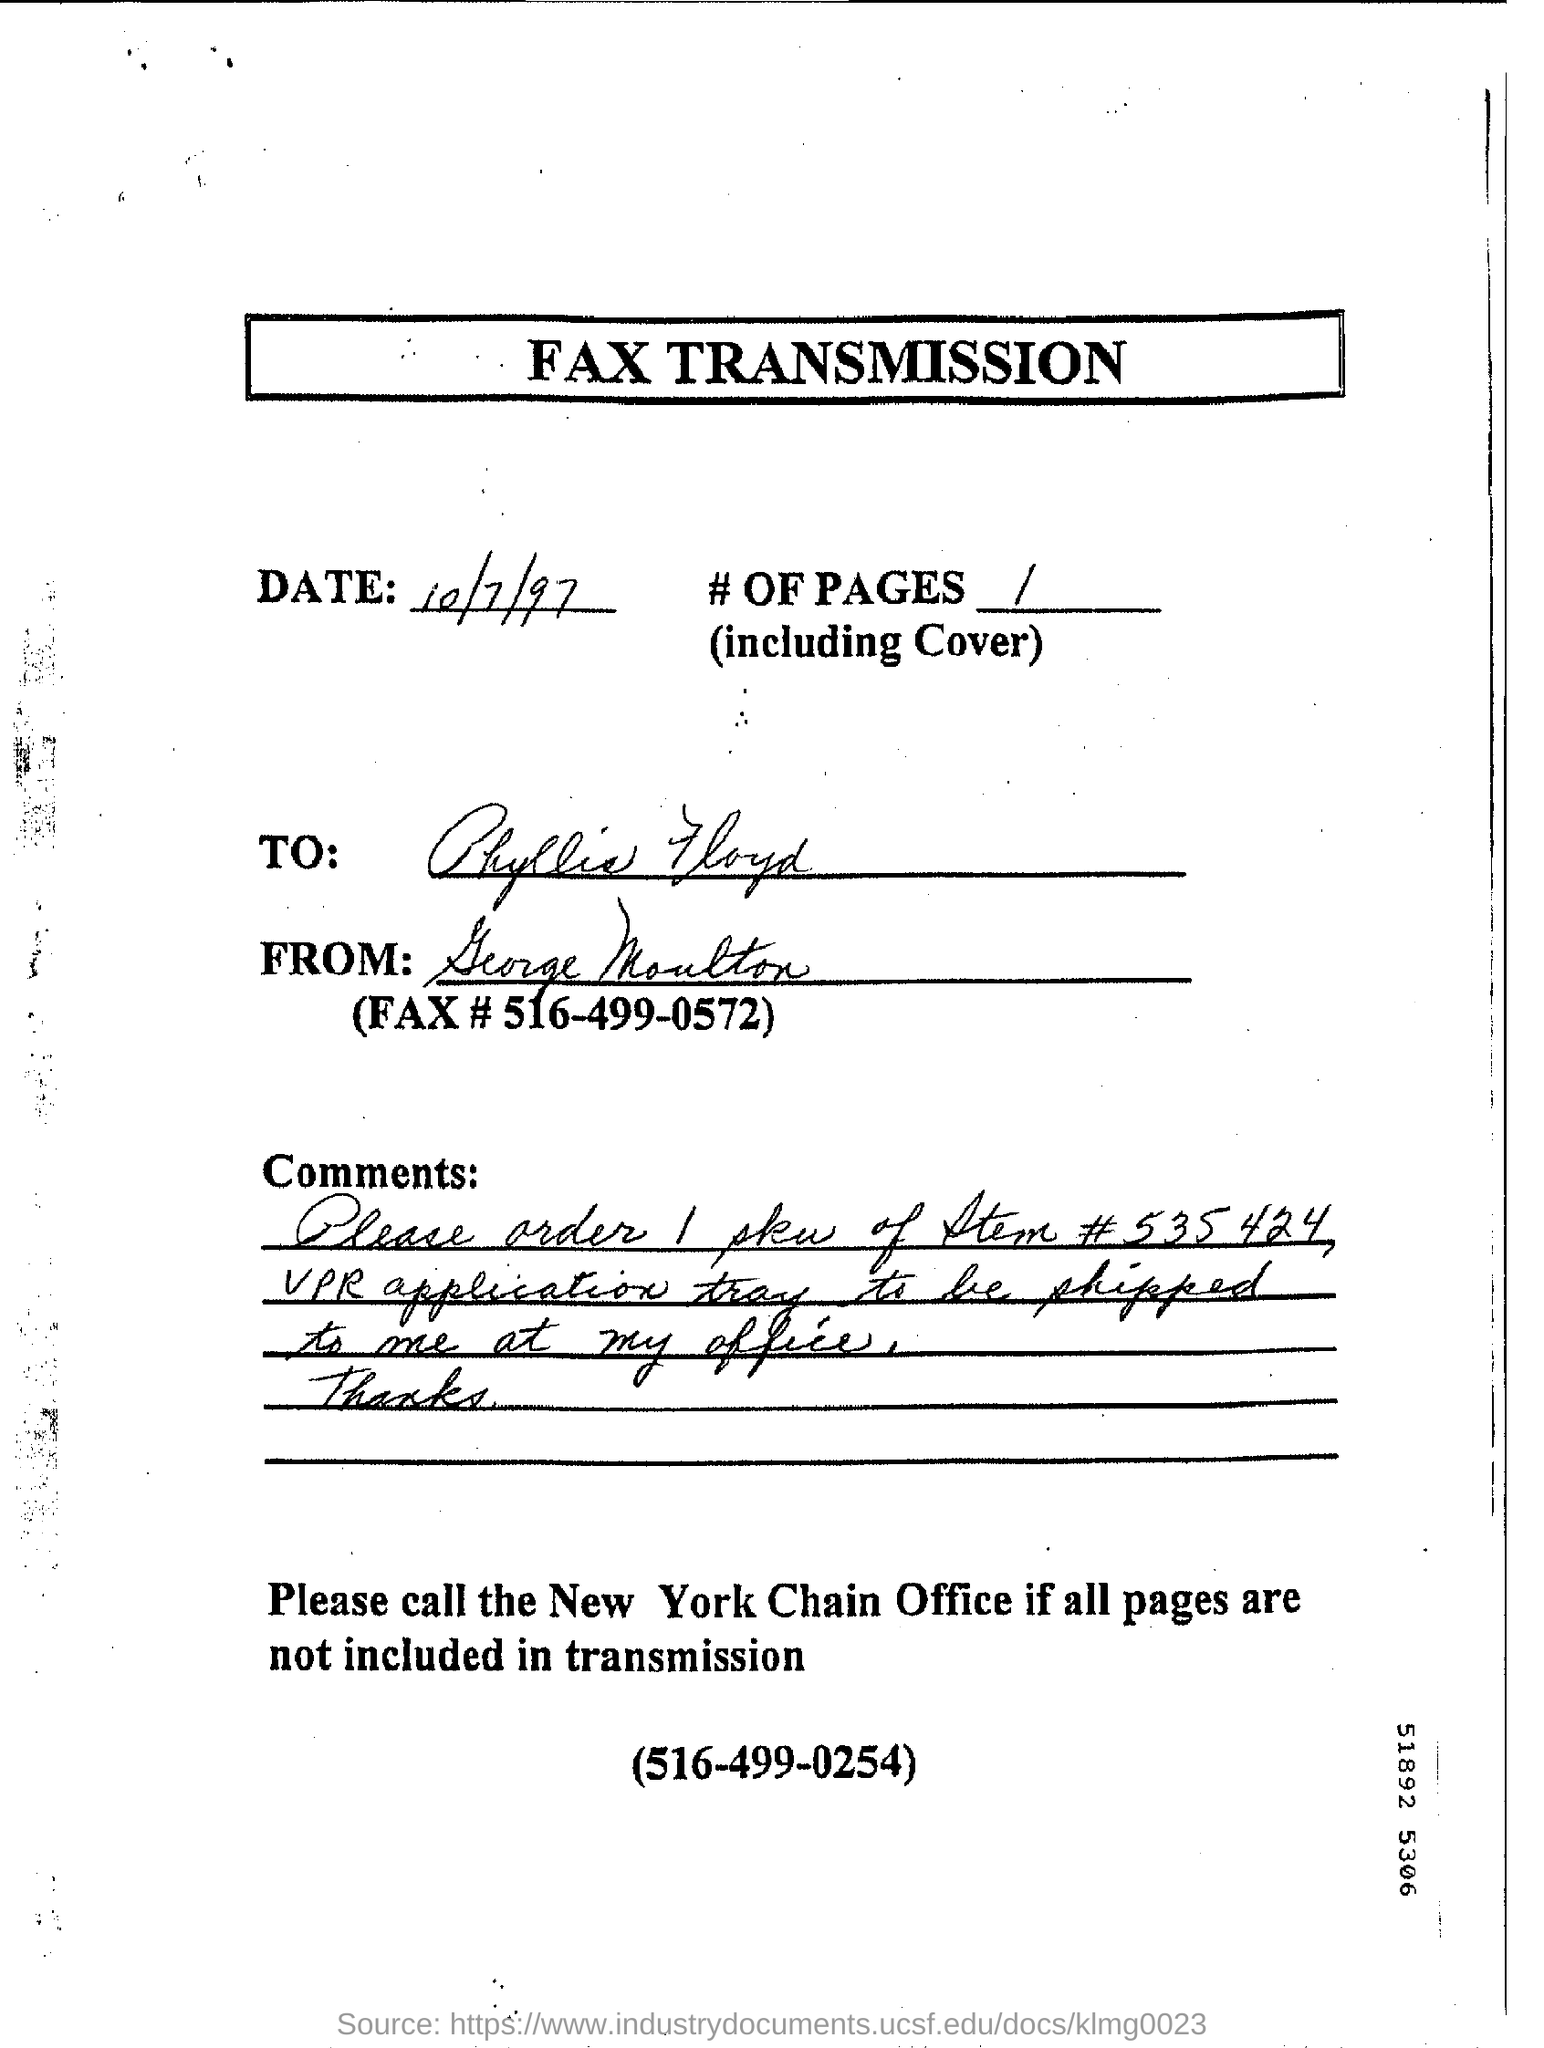What is the heading of the document?
Your answer should be compact. Fax transmission. What is the date mentioned?
Ensure brevity in your answer.  10/7/97. 